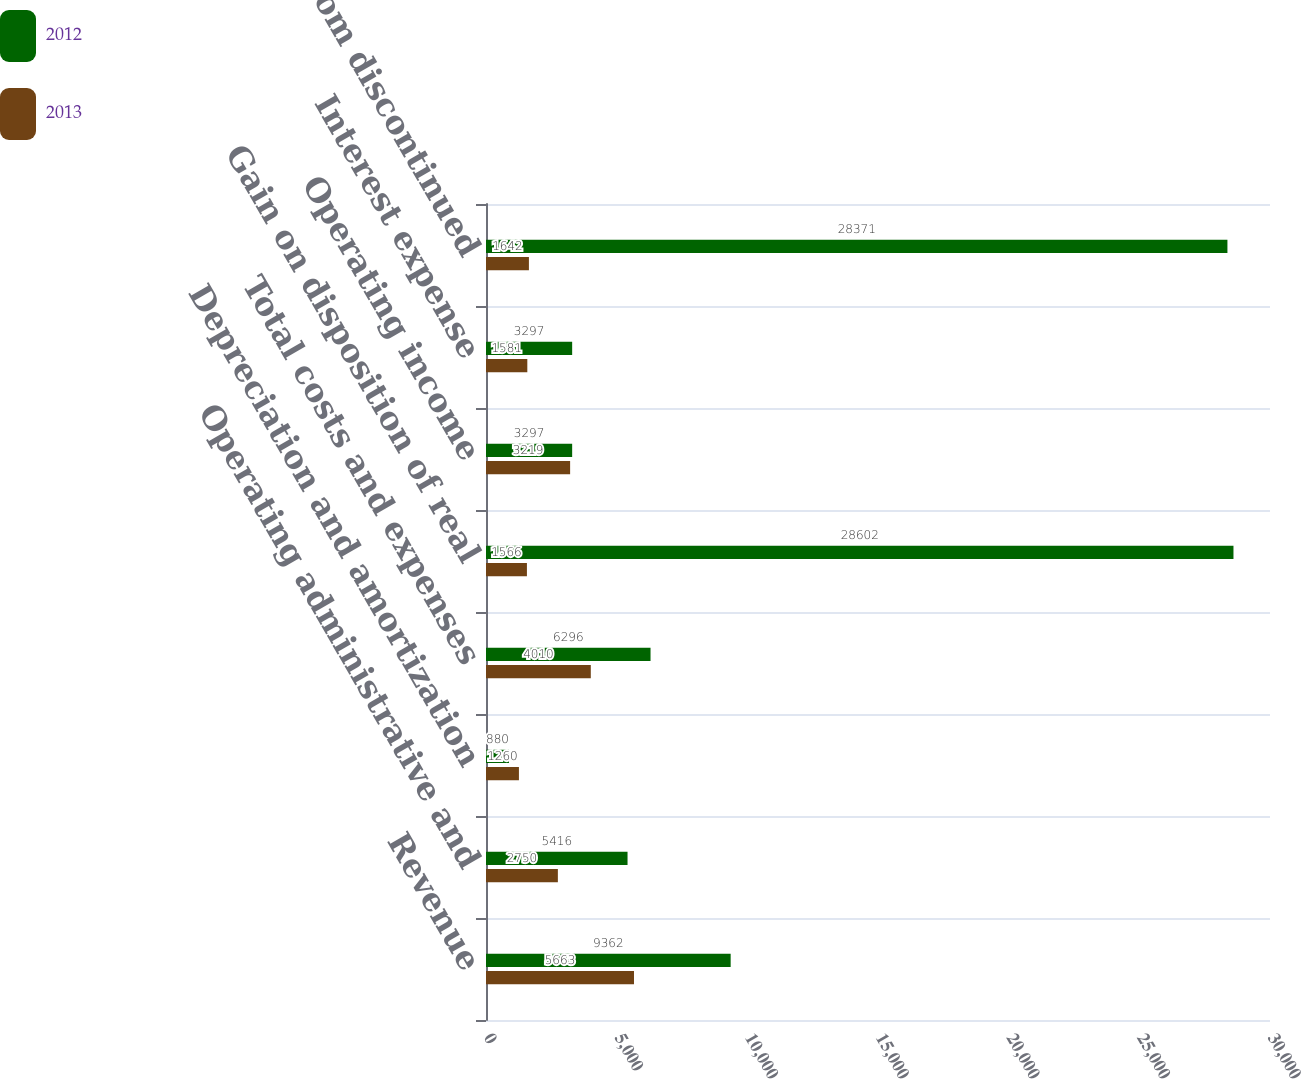Convert chart to OTSL. <chart><loc_0><loc_0><loc_500><loc_500><stacked_bar_chart><ecel><fcel>Revenue<fcel>Operating administrative and<fcel>Depreciation and amortization<fcel>Total costs and expenses<fcel>Gain on disposition of real<fcel>Operating income<fcel>Interest expense<fcel>Income from discontinued<nl><fcel>2012<fcel>9362<fcel>5416<fcel>880<fcel>6296<fcel>28602<fcel>3297<fcel>3297<fcel>28371<nl><fcel>2013<fcel>5663<fcel>2750<fcel>1260<fcel>4010<fcel>1566<fcel>3219<fcel>1581<fcel>1642<nl></chart> 